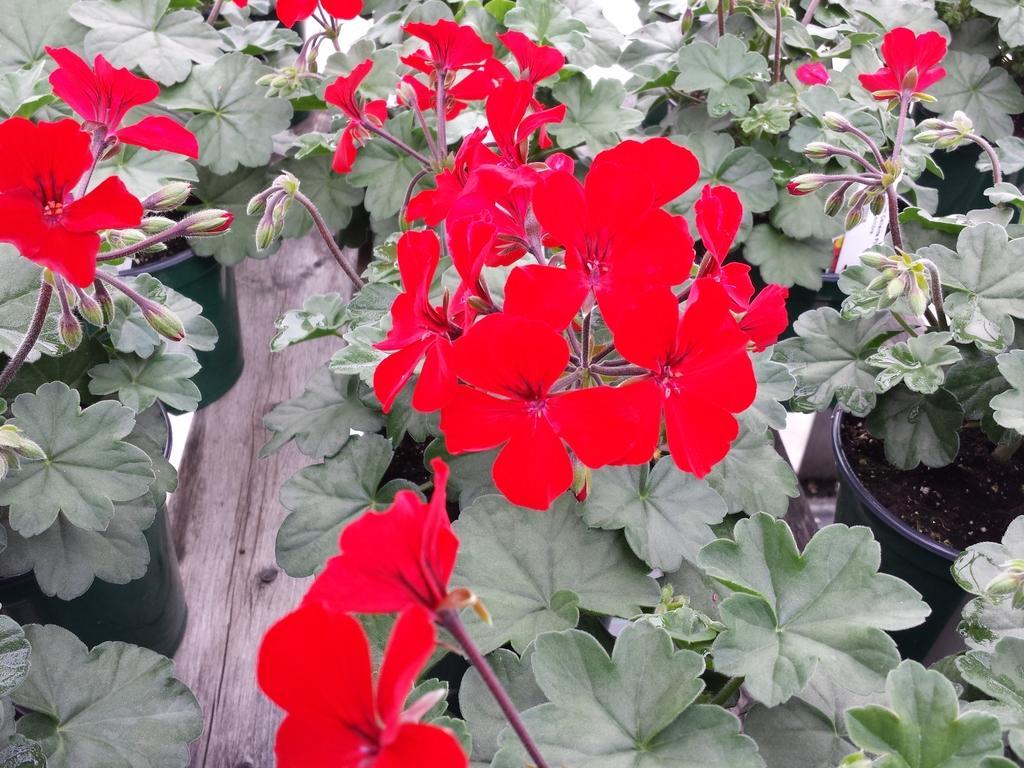Describe this image in one or two sentences. In this image we can see a group of flowering plants in different pots placed on the floor. 